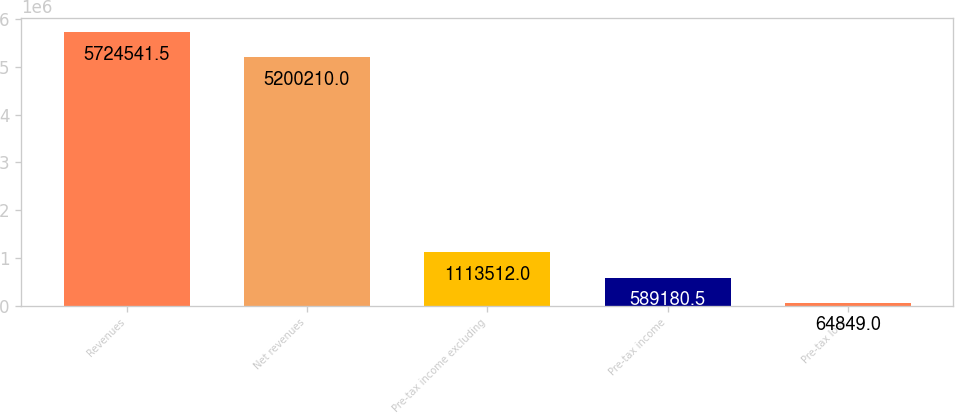Convert chart to OTSL. <chart><loc_0><loc_0><loc_500><loc_500><bar_chart><fcel>Revenues<fcel>Net revenues<fcel>Pre-tax income excluding<fcel>Pre-tax income<fcel>Pre-tax loss<nl><fcel>5.72454e+06<fcel>5.20021e+06<fcel>1.11351e+06<fcel>589180<fcel>64849<nl></chart> 